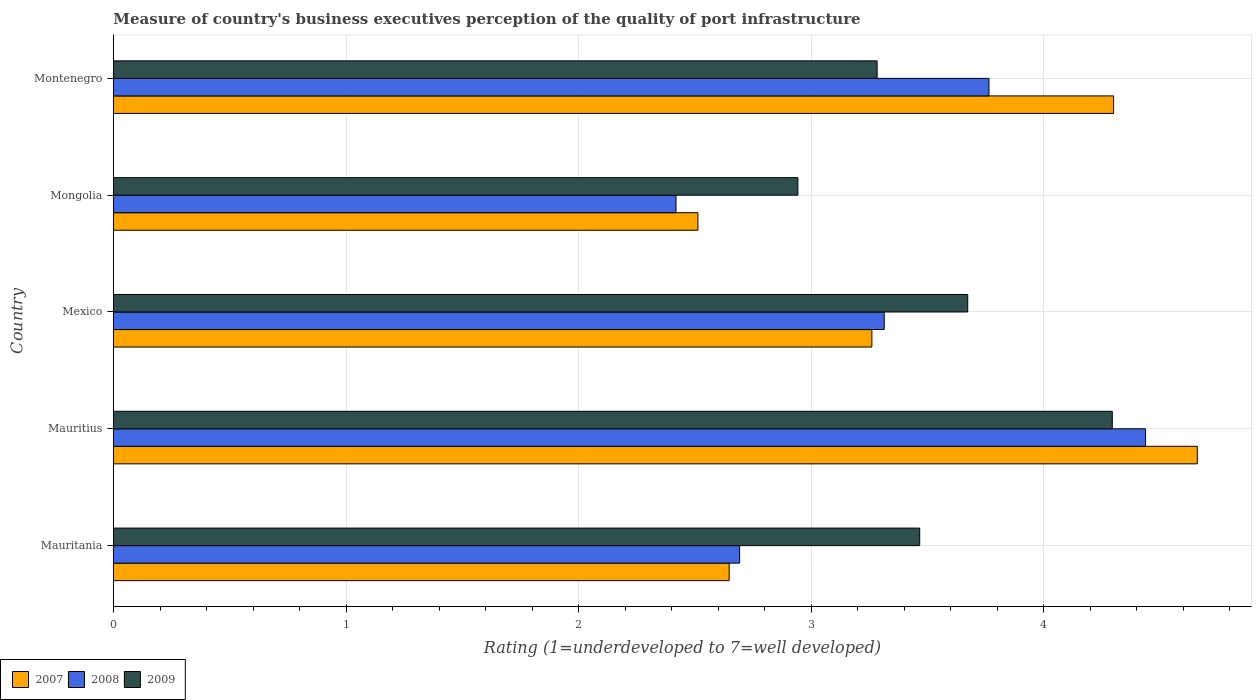How many groups of bars are there?
Your answer should be compact. 5. Are the number of bars per tick equal to the number of legend labels?
Provide a short and direct response. Yes. How many bars are there on the 3rd tick from the top?
Ensure brevity in your answer.  3. What is the label of the 5th group of bars from the top?
Provide a short and direct response. Mauritania. In how many cases, is the number of bars for a given country not equal to the number of legend labels?
Offer a very short reply. 0. What is the ratings of the quality of port infrastructure in 2009 in Montenegro?
Keep it short and to the point. 3.28. Across all countries, what is the maximum ratings of the quality of port infrastructure in 2008?
Provide a succinct answer. 4.44. Across all countries, what is the minimum ratings of the quality of port infrastructure in 2009?
Make the answer very short. 2.94. In which country was the ratings of the quality of port infrastructure in 2008 maximum?
Your answer should be very brief. Mauritius. In which country was the ratings of the quality of port infrastructure in 2009 minimum?
Ensure brevity in your answer.  Mongolia. What is the total ratings of the quality of port infrastructure in 2008 in the graph?
Offer a terse response. 16.63. What is the difference between the ratings of the quality of port infrastructure in 2007 in Mauritius and that in Montenegro?
Give a very brief answer. 0.36. What is the difference between the ratings of the quality of port infrastructure in 2009 in Mauritania and the ratings of the quality of port infrastructure in 2007 in Mexico?
Provide a succinct answer. 0.21. What is the average ratings of the quality of port infrastructure in 2007 per country?
Provide a short and direct response. 3.48. What is the difference between the ratings of the quality of port infrastructure in 2007 and ratings of the quality of port infrastructure in 2008 in Mauritania?
Your answer should be very brief. -0.04. What is the ratio of the ratings of the quality of port infrastructure in 2007 in Mauritius to that in Mongolia?
Keep it short and to the point. 1.85. Is the difference between the ratings of the quality of port infrastructure in 2007 in Mongolia and Montenegro greater than the difference between the ratings of the quality of port infrastructure in 2008 in Mongolia and Montenegro?
Provide a succinct answer. No. What is the difference between the highest and the second highest ratings of the quality of port infrastructure in 2009?
Provide a succinct answer. 0.62. What is the difference between the highest and the lowest ratings of the quality of port infrastructure in 2008?
Your response must be concise. 2.02. In how many countries, is the ratings of the quality of port infrastructure in 2008 greater than the average ratings of the quality of port infrastructure in 2008 taken over all countries?
Keep it short and to the point. 2. Is the sum of the ratings of the quality of port infrastructure in 2007 in Mauritania and Mongolia greater than the maximum ratings of the quality of port infrastructure in 2009 across all countries?
Your answer should be very brief. Yes. What does the 1st bar from the top in Montenegro represents?
Provide a short and direct response. 2009. Is it the case that in every country, the sum of the ratings of the quality of port infrastructure in 2008 and ratings of the quality of port infrastructure in 2007 is greater than the ratings of the quality of port infrastructure in 2009?
Ensure brevity in your answer.  Yes. How many countries are there in the graph?
Ensure brevity in your answer.  5. Does the graph contain grids?
Offer a terse response. Yes. Where does the legend appear in the graph?
Your answer should be very brief. Bottom left. How many legend labels are there?
Make the answer very short. 3. What is the title of the graph?
Ensure brevity in your answer.  Measure of country's business executives perception of the quality of port infrastructure. What is the label or title of the X-axis?
Your response must be concise. Rating (1=underdeveloped to 7=well developed). What is the label or title of the Y-axis?
Provide a short and direct response. Country. What is the Rating (1=underdeveloped to 7=well developed) in 2007 in Mauritania?
Offer a very short reply. 2.65. What is the Rating (1=underdeveloped to 7=well developed) in 2008 in Mauritania?
Your answer should be very brief. 2.69. What is the Rating (1=underdeveloped to 7=well developed) in 2009 in Mauritania?
Make the answer very short. 3.47. What is the Rating (1=underdeveloped to 7=well developed) of 2007 in Mauritius?
Offer a terse response. 4.66. What is the Rating (1=underdeveloped to 7=well developed) in 2008 in Mauritius?
Provide a succinct answer. 4.44. What is the Rating (1=underdeveloped to 7=well developed) in 2009 in Mauritius?
Your answer should be very brief. 4.29. What is the Rating (1=underdeveloped to 7=well developed) in 2007 in Mexico?
Offer a very short reply. 3.26. What is the Rating (1=underdeveloped to 7=well developed) of 2008 in Mexico?
Offer a very short reply. 3.31. What is the Rating (1=underdeveloped to 7=well developed) of 2009 in Mexico?
Make the answer very short. 3.67. What is the Rating (1=underdeveloped to 7=well developed) of 2007 in Mongolia?
Your answer should be very brief. 2.51. What is the Rating (1=underdeveloped to 7=well developed) in 2008 in Mongolia?
Provide a succinct answer. 2.42. What is the Rating (1=underdeveloped to 7=well developed) of 2009 in Mongolia?
Make the answer very short. 2.94. What is the Rating (1=underdeveloped to 7=well developed) of 2008 in Montenegro?
Provide a short and direct response. 3.76. What is the Rating (1=underdeveloped to 7=well developed) in 2009 in Montenegro?
Your answer should be very brief. 3.28. Across all countries, what is the maximum Rating (1=underdeveloped to 7=well developed) of 2007?
Keep it short and to the point. 4.66. Across all countries, what is the maximum Rating (1=underdeveloped to 7=well developed) of 2008?
Provide a short and direct response. 4.44. Across all countries, what is the maximum Rating (1=underdeveloped to 7=well developed) in 2009?
Your answer should be compact. 4.29. Across all countries, what is the minimum Rating (1=underdeveloped to 7=well developed) in 2007?
Give a very brief answer. 2.51. Across all countries, what is the minimum Rating (1=underdeveloped to 7=well developed) of 2008?
Your response must be concise. 2.42. Across all countries, what is the minimum Rating (1=underdeveloped to 7=well developed) of 2009?
Offer a terse response. 2.94. What is the total Rating (1=underdeveloped to 7=well developed) in 2007 in the graph?
Provide a short and direct response. 17.38. What is the total Rating (1=underdeveloped to 7=well developed) of 2008 in the graph?
Your answer should be very brief. 16.63. What is the total Rating (1=underdeveloped to 7=well developed) of 2009 in the graph?
Your answer should be compact. 17.66. What is the difference between the Rating (1=underdeveloped to 7=well developed) of 2007 in Mauritania and that in Mauritius?
Ensure brevity in your answer.  -2.01. What is the difference between the Rating (1=underdeveloped to 7=well developed) of 2008 in Mauritania and that in Mauritius?
Provide a succinct answer. -1.75. What is the difference between the Rating (1=underdeveloped to 7=well developed) of 2009 in Mauritania and that in Mauritius?
Your answer should be compact. -0.83. What is the difference between the Rating (1=underdeveloped to 7=well developed) in 2007 in Mauritania and that in Mexico?
Your answer should be compact. -0.61. What is the difference between the Rating (1=underdeveloped to 7=well developed) of 2008 in Mauritania and that in Mexico?
Your answer should be compact. -0.62. What is the difference between the Rating (1=underdeveloped to 7=well developed) in 2009 in Mauritania and that in Mexico?
Offer a very short reply. -0.21. What is the difference between the Rating (1=underdeveloped to 7=well developed) in 2007 in Mauritania and that in Mongolia?
Offer a terse response. 0.13. What is the difference between the Rating (1=underdeveloped to 7=well developed) of 2008 in Mauritania and that in Mongolia?
Provide a succinct answer. 0.27. What is the difference between the Rating (1=underdeveloped to 7=well developed) of 2009 in Mauritania and that in Mongolia?
Your answer should be very brief. 0.52. What is the difference between the Rating (1=underdeveloped to 7=well developed) in 2007 in Mauritania and that in Montenegro?
Offer a very short reply. -1.65. What is the difference between the Rating (1=underdeveloped to 7=well developed) of 2008 in Mauritania and that in Montenegro?
Make the answer very short. -1.07. What is the difference between the Rating (1=underdeveloped to 7=well developed) of 2009 in Mauritania and that in Montenegro?
Your response must be concise. 0.18. What is the difference between the Rating (1=underdeveloped to 7=well developed) in 2007 in Mauritius and that in Mexico?
Your answer should be very brief. 1.4. What is the difference between the Rating (1=underdeveloped to 7=well developed) of 2008 in Mauritius and that in Mexico?
Give a very brief answer. 1.12. What is the difference between the Rating (1=underdeveloped to 7=well developed) in 2009 in Mauritius and that in Mexico?
Keep it short and to the point. 0.62. What is the difference between the Rating (1=underdeveloped to 7=well developed) in 2007 in Mauritius and that in Mongolia?
Make the answer very short. 2.15. What is the difference between the Rating (1=underdeveloped to 7=well developed) of 2008 in Mauritius and that in Mongolia?
Your response must be concise. 2.02. What is the difference between the Rating (1=underdeveloped to 7=well developed) in 2009 in Mauritius and that in Mongolia?
Make the answer very short. 1.35. What is the difference between the Rating (1=underdeveloped to 7=well developed) of 2007 in Mauritius and that in Montenegro?
Your response must be concise. 0.36. What is the difference between the Rating (1=underdeveloped to 7=well developed) of 2008 in Mauritius and that in Montenegro?
Offer a terse response. 0.67. What is the difference between the Rating (1=underdeveloped to 7=well developed) of 2009 in Mauritius and that in Montenegro?
Your answer should be very brief. 1.01. What is the difference between the Rating (1=underdeveloped to 7=well developed) of 2007 in Mexico and that in Mongolia?
Your answer should be compact. 0.75. What is the difference between the Rating (1=underdeveloped to 7=well developed) in 2008 in Mexico and that in Mongolia?
Provide a succinct answer. 0.9. What is the difference between the Rating (1=underdeveloped to 7=well developed) in 2009 in Mexico and that in Mongolia?
Ensure brevity in your answer.  0.73. What is the difference between the Rating (1=underdeveloped to 7=well developed) of 2007 in Mexico and that in Montenegro?
Offer a very short reply. -1.04. What is the difference between the Rating (1=underdeveloped to 7=well developed) in 2008 in Mexico and that in Montenegro?
Make the answer very short. -0.45. What is the difference between the Rating (1=underdeveloped to 7=well developed) in 2009 in Mexico and that in Montenegro?
Offer a very short reply. 0.39. What is the difference between the Rating (1=underdeveloped to 7=well developed) of 2007 in Mongolia and that in Montenegro?
Offer a very short reply. -1.79. What is the difference between the Rating (1=underdeveloped to 7=well developed) in 2008 in Mongolia and that in Montenegro?
Keep it short and to the point. -1.35. What is the difference between the Rating (1=underdeveloped to 7=well developed) of 2009 in Mongolia and that in Montenegro?
Ensure brevity in your answer.  -0.34. What is the difference between the Rating (1=underdeveloped to 7=well developed) of 2007 in Mauritania and the Rating (1=underdeveloped to 7=well developed) of 2008 in Mauritius?
Your answer should be compact. -1.79. What is the difference between the Rating (1=underdeveloped to 7=well developed) in 2007 in Mauritania and the Rating (1=underdeveloped to 7=well developed) in 2009 in Mauritius?
Keep it short and to the point. -1.65. What is the difference between the Rating (1=underdeveloped to 7=well developed) in 2008 in Mauritania and the Rating (1=underdeveloped to 7=well developed) in 2009 in Mauritius?
Make the answer very short. -1.6. What is the difference between the Rating (1=underdeveloped to 7=well developed) in 2007 in Mauritania and the Rating (1=underdeveloped to 7=well developed) in 2008 in Mexico?
Offer a terse response. -0.67. What is the difference between the Rating (1=underdeveloped to 7=well developed) in 2007 in Mauritania and the Rating (1=underdeveloped to 7=well developed) in 2009 in Mexico?
Make the answer very short. -1.03. What is the difference between the Rating (1=underdeveloped to 7=well developed) of 2008 in Mauritania and the Rating (1=underdeveloped to 7=well developed) of 2009 in Mexico?
Your response must be concise. -0.98. What is the difference between the Rating (1=underdeveloped to 7=well developed) of 2007 in Mauritania and the Rating (1=underdeveloped to 7=well developed) of 2008 in Mongolia?
Offer a terse response. 0.23. What is the difference between the Rating (1=underdeveloped to 7=well developed) in 2007 in Mauritania and the Rating (1=underdeveloped to 7=well developed) in 2009 in Mongolia?
Your response must be concise. -0.3. What is the difference between the Rating (1=underdeveloped to 7=well developed) of 2008 in Mauritania and the Rating (1=underdeveloped to 7=well developed) of 2009 in Mongolia?
Provide a short and direct response. -0.25. What is the difference between the Rating (1=underdeveloped to 7=well developed) of 2007 in Mauritania and the Rating (1=underdeveloped to 7=well developed) of 2008 in Montenegro?
Your answer should be very brief. -1.12. What is the difference between the Rating (1=underdeveloped to 7=well developed) of 2007 in Mauritania and the Rating (1=underdeveloped to 7=well developed) of 2009 in Montenegro?
Give a very brief answer. -0.64. What is the difference between the Rating (1=underdeveloped to 7=well developed) in 2008 in Mauritania and the Rating (1=underdeveloped to 7=well developed) in 2009 in Montenegro?
Offer a very short reply. -0.59. What is the difference between the Rating (1=underdeveloped to 7=well developed) in 2007 in Mauritius and the Rating (1=underdeveloped to 7=well developed) in 2008 in Mexico?
Offer a terse response. 1.35. What is the difference between the Rating (1=underdeveloped to 7=well developed) in 2008 in Mauritius and the Rating (1=underdeveloped to 7=well developed) in 2009 in Mexico?
Your response must be concise. 0.76. What is the difference between the Rating (1=underdeveloped to 7=well developed) of 2007 in Mauritius and the Rating (1=underdeveloped to 7=well developed) of 2008 in Mongolia?
Your response must be concise. 2.24. What is the difference between the Rating (1=underdeveloped to 7=well developed) of 2007 in Mauritius and the Rating (1=underdeveloped to 7=well developed) of 2009 in Mongolia?
Provide a short and direct response. 1.72. What is the difference between the Rating (1=underdeveloped to 7=well developed) of 2008 in Mauritius and the Rating (1=underdeveloped to 7=well developed) of 2009 in Mongolia?
Ensure brevity in your answer.  1.49. What is the difference between the Rating (1=underdeveloped to 7=well developed) of 2007 in Mauritius and the Rating (1=underdeveloped to 7=well developed) of 2008 in Montenegro?
Give a very brief answer. 0.9. What is the difference between the Rating (1=underdeveloped to 7=well developed) in 2007 in Mauritius and the Rating (1=underdeveloped to 7=well developed) in 2009 in Montenegro?
Offer a very short reply. 1.38. What is the difference between the Rating (1=underdeveloped to 7=well developed) in 2008 in Mauritius and the Rating (1=underdeveloped to 7=well developed) in 2009 in Montenegro?
Ensure brevity in your answer.  1.15. What is the difference between the Rating (1=underdeveloped to 7=well developed) of 2007 in Mexico and the Rating (1=underdeveloped to 7=well developed) of 2008 in Mongolia?
Give a very brief answer. 0.84. What is the difference between the Rating (1=underdeveloped to 7=well developed) of 2007 in Mexico and the Rating (1=underdeveloped to 7=well developed) of 2009 in Mongolia?
Your response must be concise. 0.32. What is the difference between the Rating (1=underdeveloped to 7=well developed) in 2008 in Mexico and the Rating (1=underdeveloped to 7=well developed) in 2009 in Mongolia?
Ensure brevity in your answer.  0.37. What is the difference between the Rating (1=underdeveloped to 7=well developed) in 2007 in Mexico and the Rating (1=underdeveloped to 7=well developed) in 2008 in Montenegro?
Offer a terse response. -0.5. What is the difference between the Rating (1=underdeveloped to 7=well developed) in 2007 in Mexico and the Rating (1=underdeveloped to 7=well developed) in 2009 in Montenegro?
Provide a short and direct response. -0.02. What is the difference between the Rating (1=underdeveloped to 7=well developed) of 2008 in Mexico and the Rating (1=underdeveloped to 7=well developed) of 2009 in Montenegro?
Your response must be concise. 0.03. What is the difference between the Rating (1=underdeveloped to 7=well developed) in 2007 in Mongolia and the Rating (1=underdeveloped to 7=well developed) in 2008 in Montenegro?
Give a very brief answer. -1.25. What is the difference between the Rating (1=underdeveloped to 7=well developed) of 2007 in Mongolia and the Rating (1=underdeveloped to 7=well developed) of 2009 in Montenegro?
Provide a short and direct response. -0.77. What is the difference between the Rating (1=underdeveloped to 7=well developed) in 2008 in Mongolia and the Rating (1=underdeveloped to 7=well developed) in 2009 in Montenegro?
Your answer should be compact. -0.86. What is the average Rating (1=underdeveloped to 7=well developed) of 2007 per country?
Offer a very short reply. 3.48. What is the average Rating (1=underdeveloped to 7=well developed) in 2008 per country?
Give a very brief answer. 3.33. What is the average Rating (1=underdeveloped to 7=well developed) of 2009 per country?
Provide a succinct answer. 3.53. What is the difference between the Rating (1=underdeveloped to 7=well developed) of 2007 and Rating (1=underdeveloped to 7=well developed) of 2008 in Mauritania?
Provide a short and direct response. -0.04. What is the difference between the Rating (1=underdeveloped to 7=well developed) of 2007 and Rating (1=underdeveloped to 7=well developed) of 2009 in Mauritania?
Ensure brevity in your answer.  -0.82. What is the difference between the Rating (1=underdeveloped to 7=well developed) in 2008 and Rating (1=underdeveloped to 7=well developed) in 2009 in Mauritania?
Make the answer very short. -0.77. What is the difference between the Rating (1=underdeveloped to 7=well developed) in 2007 and Rating (1=underdeveloped to 7=well developed) in 2008 in Mauritius?
Keep it short and to the point. 0.22. What is the difference between the Rating (1=underdeveloped to 7=well developed) in 2007 and Rating (1=underdeveloped to 7=well developed) in 2009 in Mauritius?
Make the answer very short. 0.37. What is the difference between the Rating (1=underdeveloped to 7=well developed) of 2008 and Rating (1=underdeveloped to 7=well developed) of 2009 in Mauritius?
Ensure brevity in your answer.  0.14. What is the difference between the Rating (1=underdeveloped to 7=well developed) of 2007 and Rating (1=underdeveloped to 7=well developed) of 2008 in Mexico?
Give a very brief answer. -0.05. What is the difference between the Rating (1=underdeveloped to 7=well developed) in 2007 and Rating (1=underdeveloped to 7=well developed) in 2009 in Mexico?
Your response must be concise. -0.41. What is the difference between the Rating (1=underdeveloped to 7=well developed) of 2008 and Rating (1=underdeveloped to 7=well developed) of 2009 in Mexico?
Your answer should be very brief. -0.36. What is the difference between the Rating (1=underdeveloped to 7=well developed) in 2007 and Rating (1=underdeveloped to 7=well developed) in 2008 in Mongolia?
Your answer should be very brief. 0.09. What is the difference between the Rating (1=underdeveloped to 7=well developed) of 2007 and Rating (1=underdeveloped to 7=well developed) of 2009 in Mongolia?
Your answer should be compact. -0.43. What is the difference between the Rating (1=underdeveloped to 7=well developed) in 2008 and Rating (1=underdeveloped to 7=well developed) in 2009 in Mongolia?
Your answer should be compact. -0.52. What is the difference between the Rating (1=underdeveloped to 7=well developed) of 2007 and Rating (1=underdeveloped to 7=well developed) of 2008 in Montenegro?
Provide a succinct answer. 0.54. What is the difference between the Rating (1=underdeveloped to 7=well developed) in 2007 and Rating (1=underdeveloped to 7=well developed) in 2009 in Montenegro?
Give a very brief answer. 1.02. What is the difference between the Rating (1=underdeveloped to 7=well developed) in 2008 and Rating (1=underdeveloped to 7=well developed) in 2009 in Montenegro?
Your response must be concise. 0.48. What is the ratio of the Rating (1=underdeveloped to 7=well developed) of 2007 in Mauritania to that in Mauritius?
Your answer should be very brief. 0.57. What is the ratio of the Rating (1=underdeveloped to 7=well developed) of 2008 in Mauritania to that in Mauritius?
Ensure brevity in your answer.  0.61. What is the ratio of the Rating (1=underdeveloped to 7=well developed) of 2009 in Mauritania to that in Mauritius?
Offer a terse response. 0.81. What is the ratio of the Rating (1=underdeveloped to 7=well developed) in 2007 in Mauritania to that in Mexico?
Provide a succinct answer. 0.81. What is the ratio of the Rating (1=underdeveloped to 7=well developed) in 2008 in Mauritania to that in Mexico?
Keep it short and to the point. 0.81. What is the ratio of the Rating (1=underdeveloped to 7=well developed) of 2009 in Mauritania to that in Mexico?
Your answer should be very brief. 0.94. What is the ratio of the Rating (1=underdeveloped to 7=well developed) in 2007 in Mauritania to that in Mongolia?
Offer a terse response. 1.05. What is the ratio of the Rating (1=underdeveloped to 7=well developed) of 2008 in Mauritania to that in Mongolia?
Offer a very short reply. 1.11. What is the ratio of the Rating (1=underdeveloped to 7=well developed) in 2009 in Mauritania to that in Mongolia?
Make the answer very short. 1.18. What is the ratio of the Rating (1=underdeveloped to 7=well developed) of 2007 in Mauritania to that in Montenegro?
Ensure brevity in your answer.  0.62. What is the ratio of the Rating (1=underdeveloped to 7=well developed) in 2008 in Mauritania to that in Montenegro?
Make the answer very short. 0.72. What is the ratio of the Rating (1=underdeveloped to 7=well developed) of 2009 in Mauritania to that in Montenegro?
Make the answer very short. 1.06. What is the ratio of the Rating (1=underdeveloped to 7=well developed) in 2007 in Mauritius to that in Mexico?
Make the answer very short. 1.43. What is the ratio of the Rating (1=underdeveloped to 7=well developed) in 2008 in Mauritius to that in Mexico?
Your answer should be very brief. 1.34. What is the ratio of the Rating (1=underdeveloped to 7=well developed) in 2009 in Mauritius to that in Mexico?
Make the answer very short. 1.17. What is the ratio of the Rating (1=underdeveloped to 7=well developed) of 2007 in Mauritius to that in Mongolia?
Provide a succinct answer. 1.85. What is the ratio of the Rating (1=underdeveloped to 7=well developed) of 2008 in Mauritius to that in Mongolia?
Your answer should be compact. 1.83. What is the ratio of the Rating (1=underdeveloped to 7=well developed) of 2009 in Mauritius to that in Mongolia?
Ensure brevity in your answer.  1.46. What is the ratio of the Rating (1=underdeveloped to 7=well developed) in 2007 in Mauritius to that in Montenegro?
Ensure brevity in your answer.  1.08. What is the ratio of the Rating (1=underdeveloped to 7=well developed) in 2008 in Mauritius to that in Montenegro?
Provide a succinct answer. 1.18. What is the ratio of the Rating (1=underdeveloped to 7=well developed) of 2009 in Mauritius to that in Montenegro?
Keep it short and to the point. 1.31. What is the ratio of the Rating (1=underdeveloped to 7=well developed) in 2007 in Mexico to that in Mongolia?
Your answer should be very brief. 1.3. What is the ratio of the Rating (1=underdeveloped to 7=well developed) of 2008 in Mexico to that in Mongolia?
Provide a short and direct response. 1.37. What is the ratio of the Rating (1=underdeveloped to 7=well developed) of 2009 in Mexico to that in Mongolia?
Provide a succinct answer. 1.25. What is the ratio of the Rating (1=underdeveloped to 7=well developed) of 2007 in Mexico to that in Montenegro?
Your response must be concise. 0.76. What is the ratio of the Rating (1=underdeveloped to 7=well developed) of 2008 in Mexico to that in Montenegro?
Your answer should be compact. 0.88. What is the ratio of the Rating (1=underdeveloped to 7=well developed) of 2009 in Mexico to that in Montenegro?
Offer a terse response. 1.12. What is the ratio of the Rating (1=underdeveloped to 7=well developed) of 2007 in Mongolia to that in Montenegro?
Give a very brief answer. 0.58. What is the ratio of the Rating (1=underdeveloped to 7=well developed) of 2008 in Mongolia to that in Montenegro?
Provide a short and direct response. 0.64. What is the ratio of the Rating (1=underdeveloped to 7=well developed) in 2009 in Mongolia to that in Montenegro?
Ensure brevity in your answer.  0.9. What is the difference between the highest and the second highest Rating (1=underdeveloped to 7=well developed) in 2007?
Your answer should be very brief. 0.36. What is the difference between the highest and the second highest Rating (1=underdeveloped to 7=well developed) of 2008?
Ensure brevity in your answer.  0.67. What is the difference between the highest and the second highest Rating (1=underdeveloped to 7=well developed) in 2009?
Your answer should be compact. 0.62. What is the difference between the highest and the lowest Rating (1=underdeveloped to 7=well developed) of 2007?
Give a very brief answer. 2.15. What is the difference between the highest and the lowest Rating (1=underdeveloped to 7=well developed) of 2008?
Give a very brief answer. 2.02. What is the difference between the highest and the lowest Rating (1=underdeveloped to 7=well developed) of 2009?
Offer a very short reply. 1.35. 